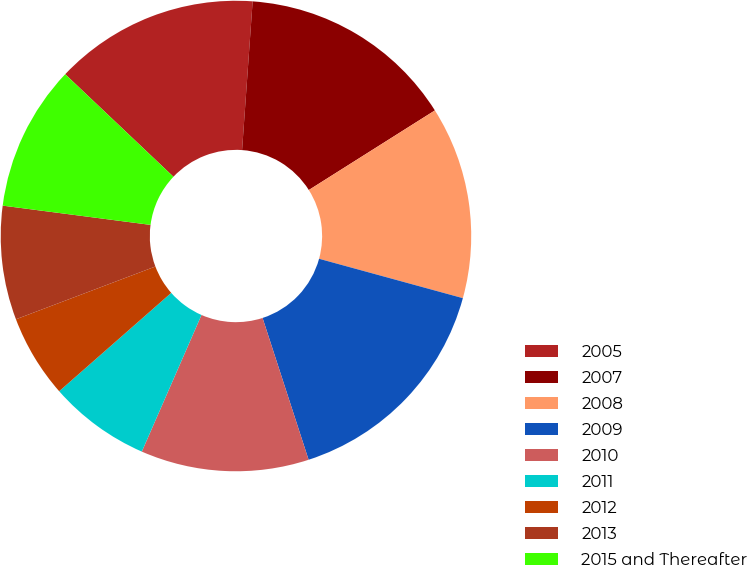Convert chart to OTSL. <chart><loc_0><loc_0><loc_500><loc_500><pie_chart><fcel>2005<fcel>2007<fcel>2008<fcel>2009<fcel>2010<fcel>2011<fcel>2012<fcel>2013<fcel>2015 and Thereafter<nl><fcel>14.06%<fcel>14.91%<fcel>13.22%<fcel>15.75%<fcel>11.55%<fcel>6.98%<fcel>5.71%<fcel>7.82%<fcel>10.01%<nl></chart> 